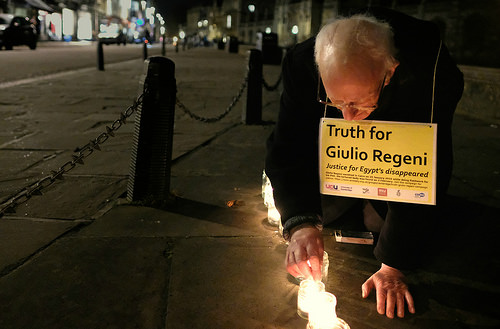<image>
Is the truth above the justice? Yes. The truth is positioned above the justice in the vertical space, higher up in the scene. 